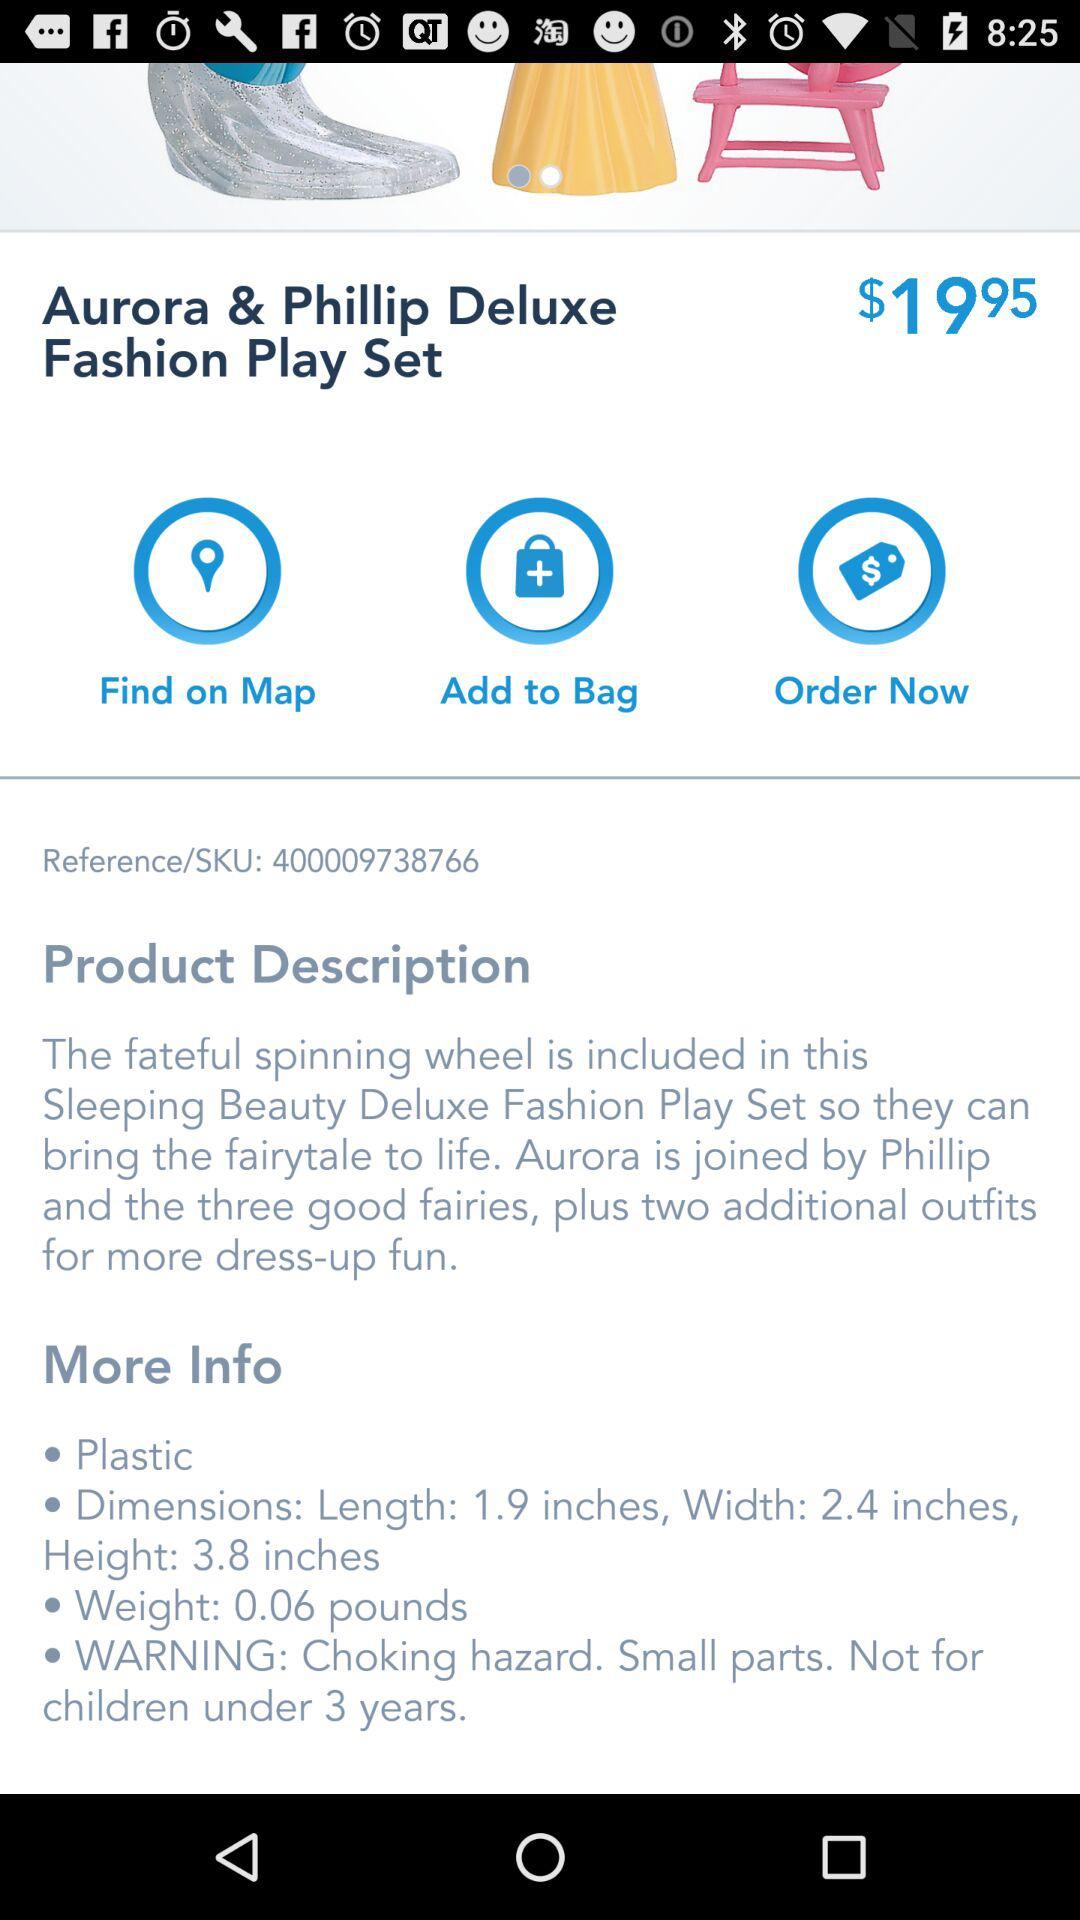How much does the product weigh?
Answer the question using a single word or phrase. 0.06 pounds 